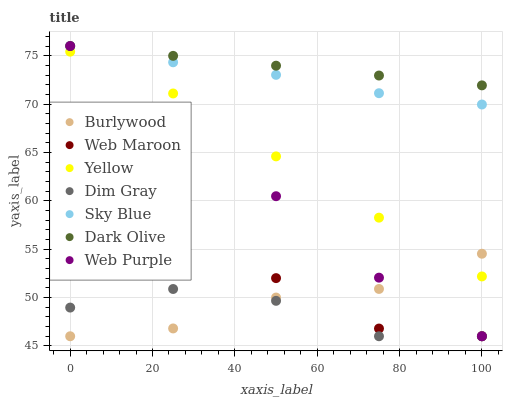Does Dim Gray have the minimum area under the curve?
Answer yes or no. Yes. Does Dark Olive have the maximum area under the curve?
Answer yes or no. Yes. Does Burlywood have the minimum area under the curve?
Answer yes or no. No. Does Burlywood have the maximum area under the curve?
Answer yes or no. No. Is Dark Olive the smoothest?
Answer yes or no. Yes. Is Web Maroon the roughest?
Answer yes or no. Yes. Is Burlywood the smoothest?
Answer yes or no. No. Is Burlywood the roughest?
Answer yes or no. No. Does Dim Gray have the lowest value?
Answer yes or no. Yes. Does Dark Olive have the lowest value?
Answer yes or no. No. Does Sky Blue have the highest value?
Answer yes or no. Yes. Does Burlywood have the highest value?
Answer yes or no. No. Is Web Maroon less than Yellow?
Answer yes or no. Yes. Is Yellow greater than Dim Gray?
Answer yes or no. Yes. Does Web Purple intersect Sky Blue?
Answer yes or no. Yes. Is Web Purple less than Sky Blue?
Answer yes or no. No. Is Web Purple greater than Sky Blue?
Answer yes or no. No. Does Web Maroon intersect Yellow?
Answer yes or no. No. 